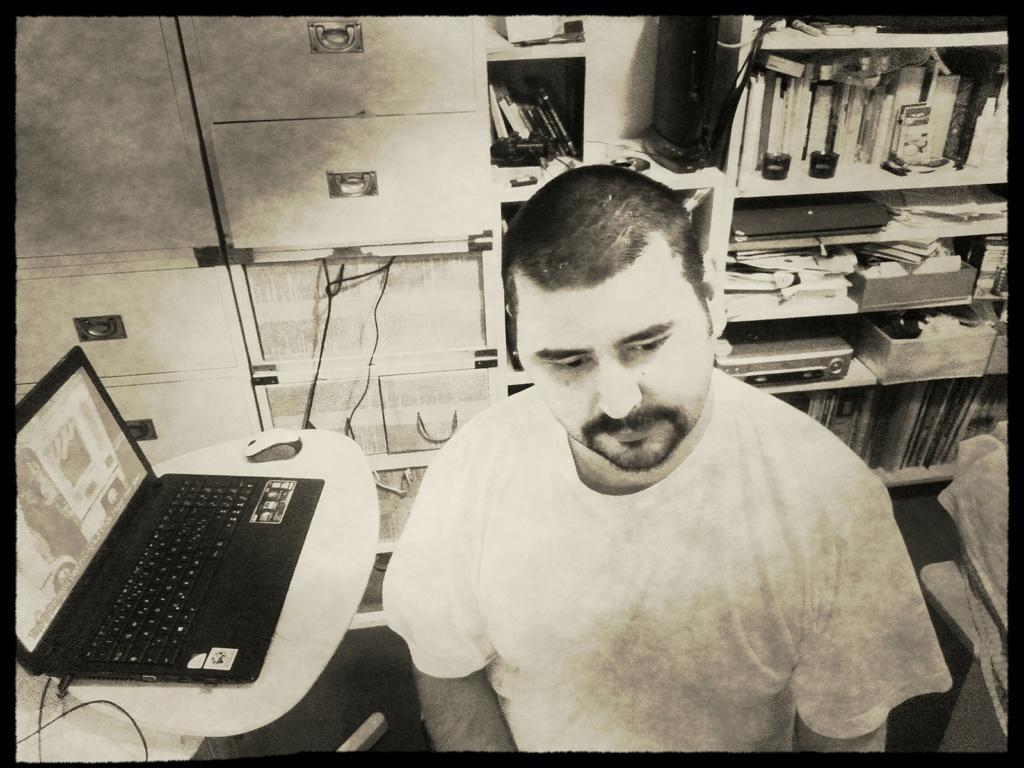Can you describe this image briefly? This is a black and white picture. In this image, we can see a person. Beside him, we can see laptop and mouse on the table. In the background, we can see cupboards and racks. On these racks, there are so many things, books and objects are placed. 